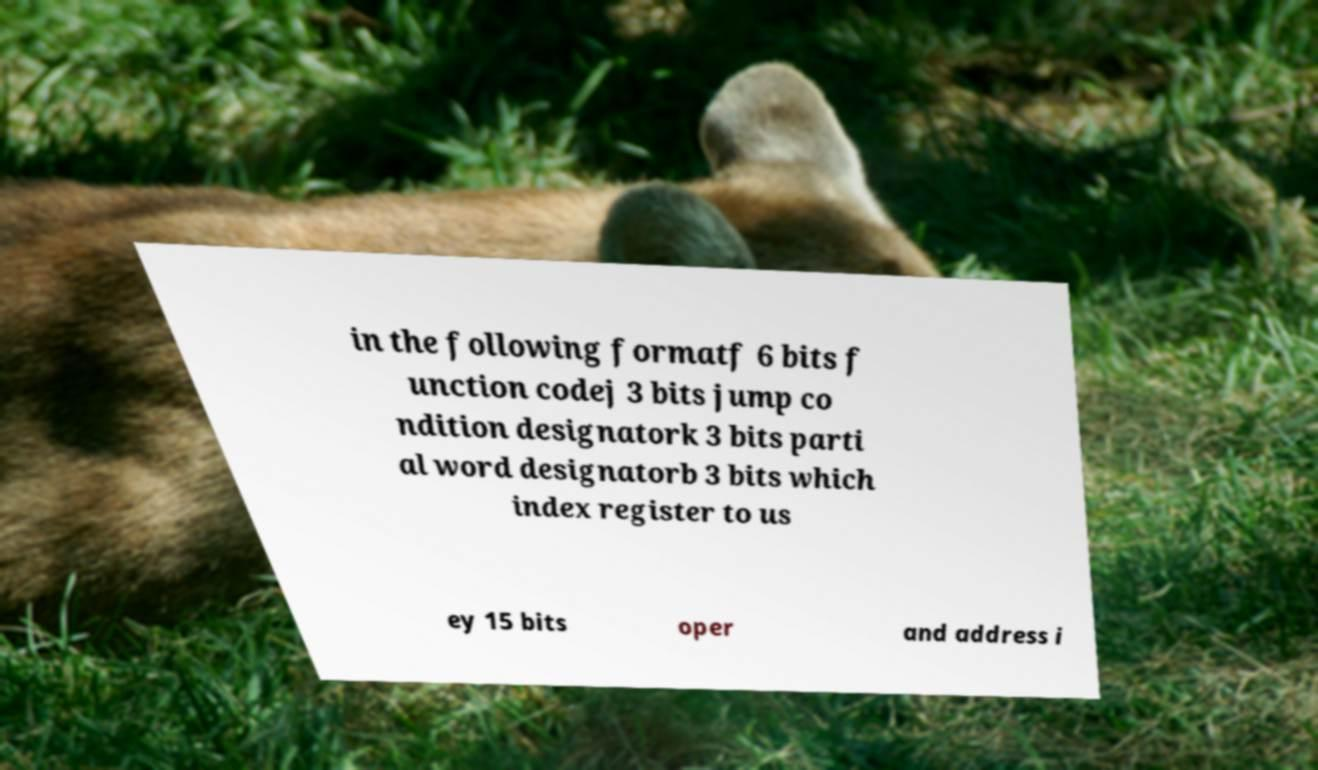Can you accurately transcribe the text from the provided image for me? in the following formatf 6 bits f unction codej 3 bits jump co ndition designatork 3 bits parti al word designatorb 3 bits which index register to us ey 15 bits oper and address i 